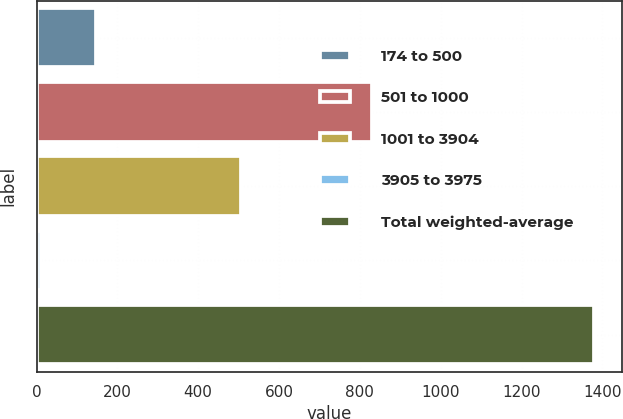Convert chart. <chart><loc_0><loc_0><loc_500><loc_500><bar_chart><fcel>174 to 500<fcel>501 to 1000<fcel>1001 to 3904<fcel>3905 to 3975<fcel>Total weighted-average<nl><fcel>147.9<fcel>829<fcel>505<fcel>11<fcel>1380<nl></chart> 